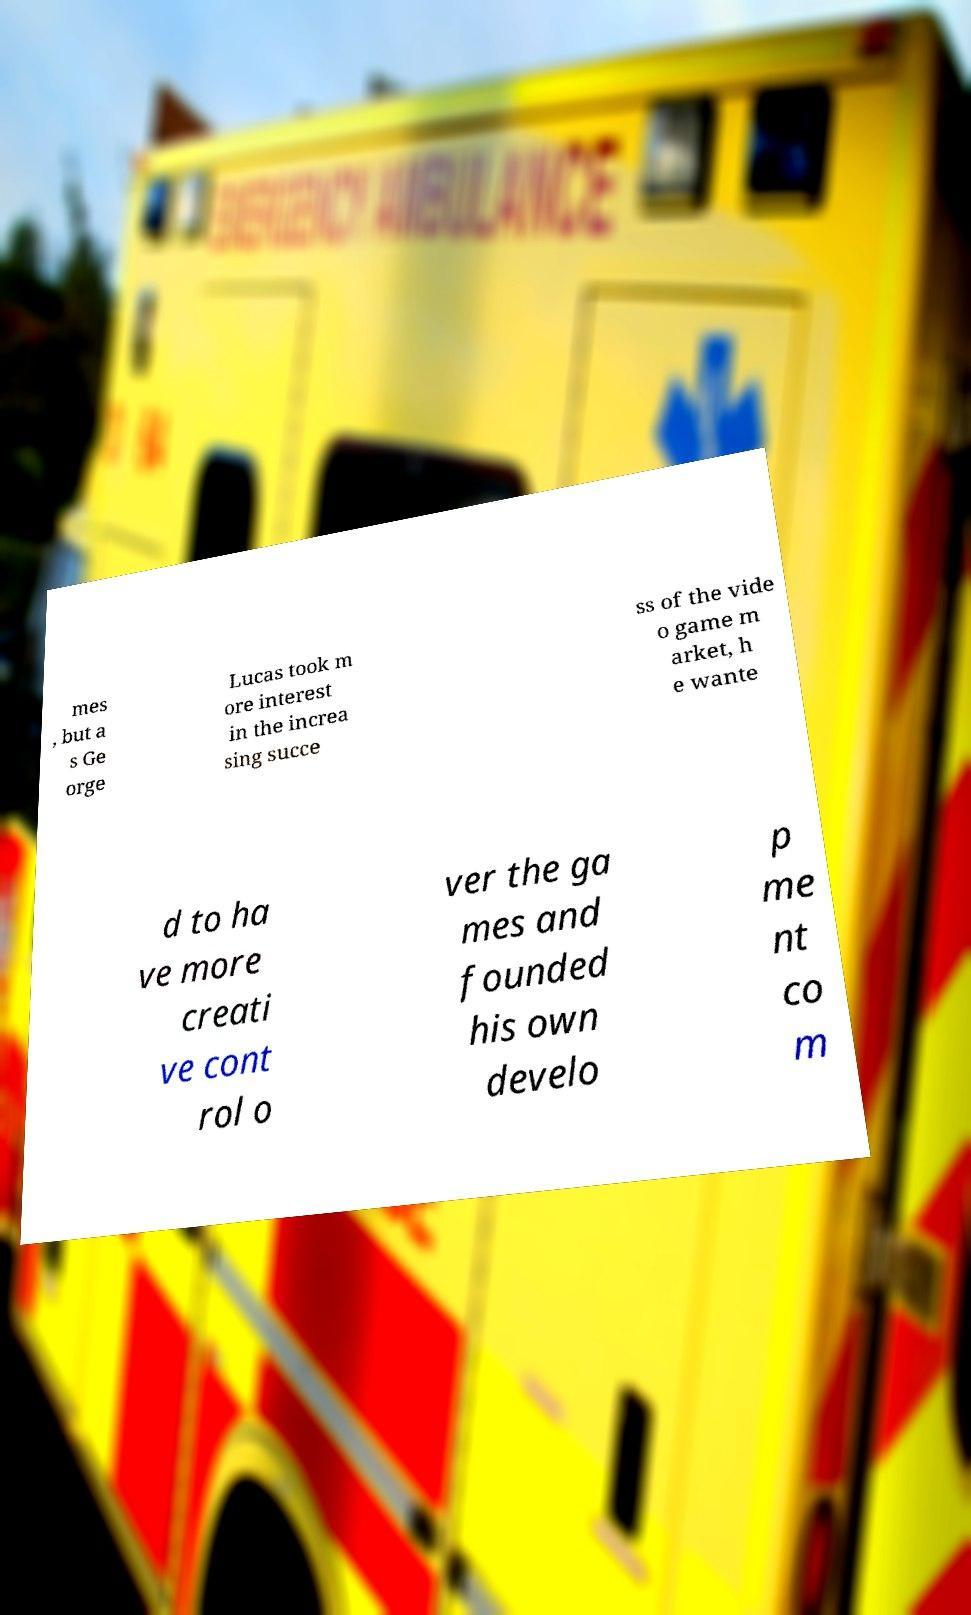For documentation purposes, I need the text within this image transcribed. Could you provide that? mes , but a s Ge orge Lucas took m ore interest in the increa sing succe ss of the vide o game m arket, h e wante d to ha ve more creati ve cont rol o ver the ga mes and founded his own develo p me nt co m 